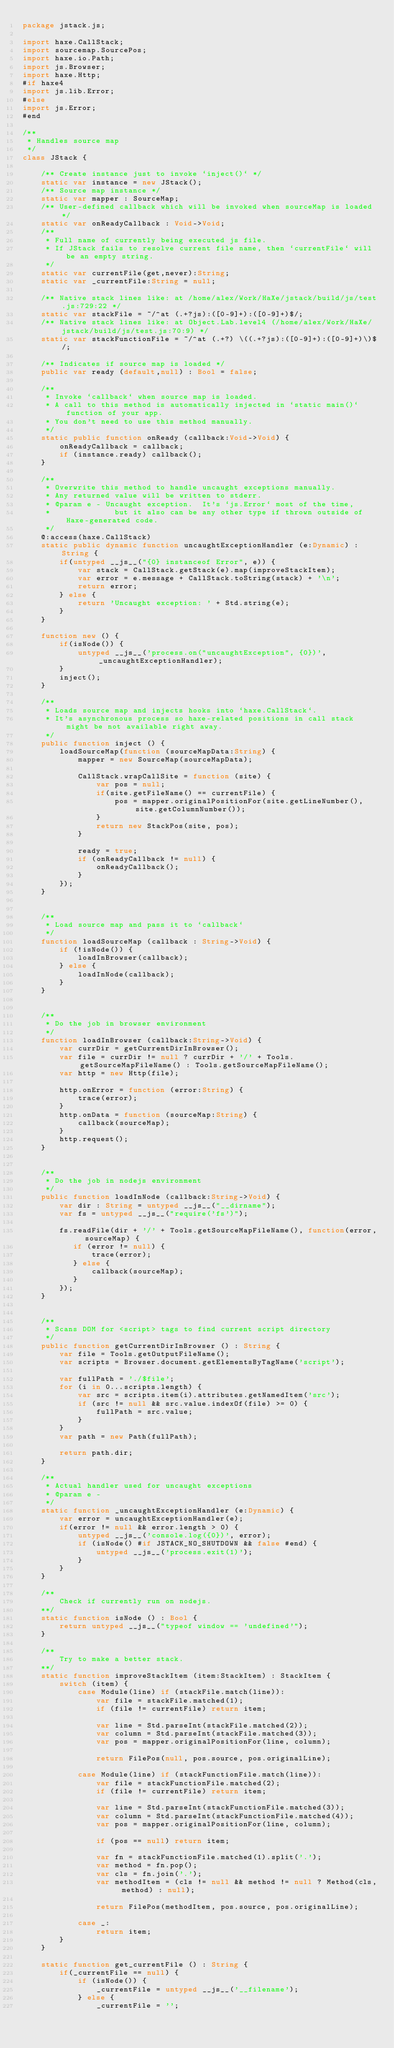Convert code to text. <code><loc_0><loc_0><loc_500><loc_500><_Haxe_>package jstack.js;

import haxe.CallStack;
import sourcemap.SourcePos;
import haxe.io.Path;
import js.Browser;
import haxe.Http;
#if haxe4
import js.lib.Error;
#else
import js.Error;
#end

/**
 * Handles source map
 */
class JStack {

    /** Create instance just to invoke `inject()` */
    static var instance = new JStack();
    /** Source map instance */
    static var mapper : SourceMap;
    /** User-defined callback which will be invoked when sourceMap is loaded */
    static var onReadyCallback : Void->Void;
    /**
     * Full name of currently being executed js file.
     * If JStack fails to resolve current file name, then `currentFile` will be an empty string.
     */
    static var currentFile(get,never):String;
    static var _currentFile:String = null;

    /** Native stack lines like: at /home/alex/Work/HaXe/jstack/build/js/test.js:729:22 */
    static var stackFile = ~/^at (.+?js):([0-9]+):([0-9]+)$/;
    /** Native stack lines like: at Object.Lab.level4 (/home/alex/Work/HaXe/jstack/build/js/test.js:70:9) */
    static var stackFunctionFile = ~/^at (.+?) \((.+?js):([0-9]+):([0-9]+)\)$/;

    /** Indicates if source map is loaded */
    public var ready (default,null) : Bool = false;

    /**
     * Invoke `callback` when source map is loaded.
     * A call to this method is automatically injected in `static main()` function of your app.
     * You don't need to use this method manually.
     */
    static public function onReady (callback:Void->Void) {
        onReadyCallback = callback;
        if (instance.ready) callback();
    }

    /**
     * Overwrite this method to handle uncaught exceptions manually.
     * Any returned value will be written to stderr.
     * @param e - Uncaught exception.  It's `js.Error` most of the time,
     *              but it also can be any other type if thrown outside of Haxe-generated code.
     */
    @:access(haxe.CallStack)
    static public dynamic function uncaughtExceptionHandler (e:Dynamic) : String {
        if(untyped __js__("{0} instanceof Error", e)) {
            var stack = CallStack.getStack(e).map(improveStackItem);
            var error = e.message + CallStack.toString(stack) + '\n';
            return error;
        } else {
            return 'Uncaught exception: ' + Std.string(e);
        }
    }

    function new () {
        if(isNode()) {
            untyped __js__('process.on("uncaughtException", {0})', _uncaughtExceptionHandler);
        }
        inject();
    }

    /**
     * Loads source map and injects hooks into `haxe.CallStack`.
     * It's asynchronous process so haxe-related positions in call stack might be not available right away.
     */
    public function inject () {
        loadSourceMap(function (sourceMapData:String) {
            mapper = new SourceMap(sourceMapData);

            CallStack.wrapCallSite = function (site) {
                var pos = null;
                if(site.getFileName() == currentFile) {
                    pos = mapper.originalPositionFor(site.getLineNumber(), site.getColumnNumber());
                }
                return new StackPos(site, pos);
            }

            ready = true;
            if (onReadyCallback != null) {
                onReadyCallback();
            }
        });
    }


    /**
     * Load source map and pass it to `callback`
     */
    function loadSourceMap (callback : String->Void) {
        if (!isNode()) {
            loadInBrowser(callback);
        } else {
            loadInNode(callback);
        }
    }


    /**
     * Do the job in browser environment
     */
    function loadInBrowser (callback:String->Void) {
        var currDir = getCurrentDirInBrowser();
        var file = currDir != null ? currDir + '/' + Tools.getSourceMapFileName() : Tools.getSourceMapFileName();
        var http = new Http(file);

        http.onError = function (error:String) {
            trace(error);
        }
        http.onData = function (sourceMap:String) {
            callback(sourceMap);
        }
        http.request();
    }


    /**
     * Do the job in nodejs environment
     */
    public function loadInNode (callback:String->Void) {
        var dir : String = untyped __js__("__dirname");
        var fs = untyped __js__("require('fs')");

        fs.readFile(dir + '/' + Tools.getSourceMapFileName(), function(error, sourceMap) {
           if (error != null) {
               trace(error);
           } else {
               callback(sourceMap);
           }
        });
    }


    /**
     * Scans DOM for <script> tags to find current script directory
     */
    public function getCurrentDirInBrowser () : String {
        var file = Tools.getOutputFileName();
        var scripts = Browser.document.getElementsByTagName('script');

        var fullPath = './$file';
        for (i in 0...scripts.length) {
            var src = scripts.item(i).attributes.getNamedItem('src');
            if (src != null && src.value.indexOf(file) >= 0) {
                fullPath = src.value;
            }
        }
        var path = new Path(fullPath);

        return path.dir;
    }

    /**
     * Actual handler used for uncaught exceptions
     * @param e -
     */
    static function _uncaughtExceptionHandler (e:Dynamic) {
        var error = uncaughtExceptionHandler(e);
        if(error != null && error.length > 0) {
            untyped __js__('console.log({0})', error);
            if (isNode() #if JSTACK_NO_SHUTDOWN && false #end) {
                untyped __js__('process.exit(1)');
            }
        }
    }

    /**
        Check if currently run on nodejs.
    **/
    static function isNode () : Bool {
        return untyped __js__("typeof window == 'undefined'");
    }

    /**
        Try to make a better stack.
    **/
    static function improveStackItem (item:StackItem) : StackItem {
        switch (item) {
            case Module(line) if (stackFile.match(line)):
                var file = stackFile.matched(1);
                if (file != currentFile) return item;

                var line = Std.parseInt(stackFile.matched(2));
                var column = Std.parseInt(stackFile.matched(3));
                var pos = mapper.originalPositionFor(line, column);

                return FilePos(null, pos.source, pos.originalLine);

            case Module(line) if (stackFunctionFile.match(line)):
                var file = stackFunctionFile.matched(2);
                if (file != currentFile) return item;

                var line = Std.parseInt(stackFunctionFile.matched(3));
                var column = Std.parseInt(stackFunctionFile.matched(4));
                var pos = mapper.originalPositionFor(line, column);

                if (pos == null) return item;

                var fn = stackFunctionFile.matched(1).split('.');
                var method = fn.pop();
                var cls = fn.join('.');
                var methodItem = (cls != null && method != null ? Method(cls, method) : null);

                return FilePos(methodItem, pos.source, pos.originalLine);

            case _:
                return item;
        }
    }

    static function get_currentFile () : String {
        if(_currentFile == null) {
            if (isNode()) {
                _currentFile = untyped __js__('__filename');
            } else {
                _currentFile = '';</code> 